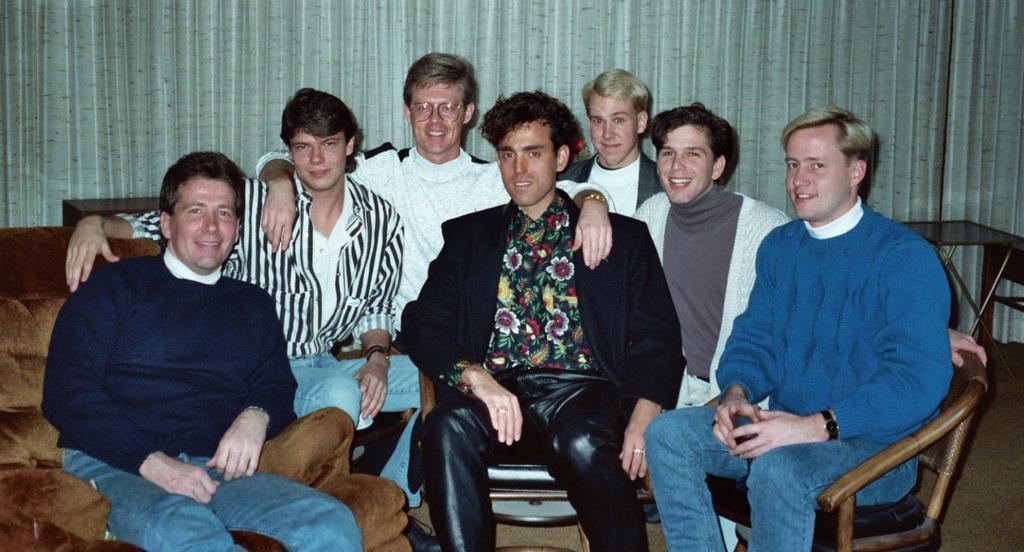How would you summarize this image in a sentence or two? The group of people are sitting on a chair and couch. The man sitting on a couch wore blue t-shirt and he smiles. The man in white t-shirt wore spectacles and wrist watch. This man sitting on a chair wore blue t-shirt and wrist watch. The person sitting in a middle wore black jacket, summer shirt and black trouser. Far there is a table. Backside of this group of people there is a curtain. 